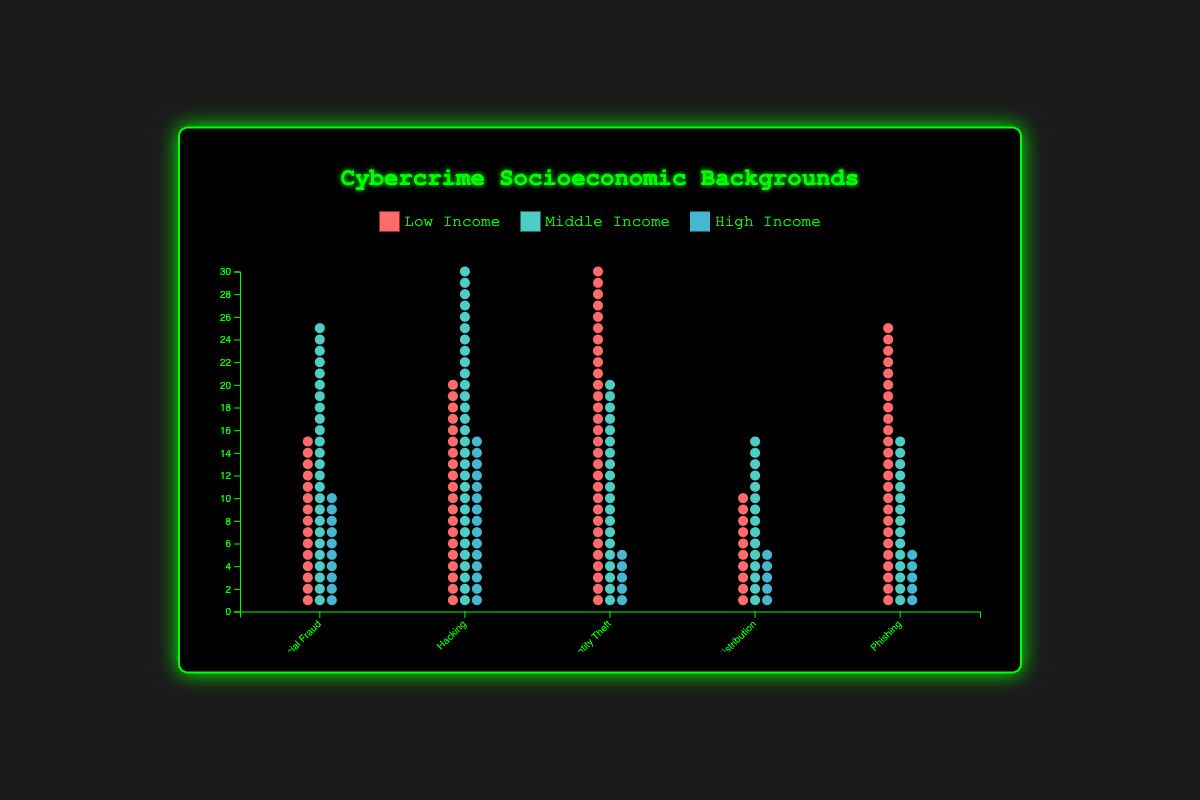What category has the highest representation of low-income cybercriminals? Look at the bars representing low-income backgrounds across all categories. The category with the tallest bar in the "low-income" color represents the highest count.
Answer: Identity Theft Which category has the least participation from high-income backgrounds? Observe the bars representing high-income backgrounds across all categories. The category with the shortest bar in the "high-income" color signifies the least count.
Answer: Identity Theft, Malware Distribution, Phishing What is the total number of middle-income individuals involved in cybercrimes? Sum up the values for middle-income individuals from all categories. 25 (Financial Fraud) + 30 (Hacking) + 20 (Identity Theft) + 15 (Malware Distribution) + 15 (Phishing) = 105
Answer: 105 How does financial fraud compare to hacking in terms of low-income background representation? Compare the two bars representing low-income backgrounds for Financial Fraud (15) and Hacking (20).
Answer: Hacking has more low-income representation What is the total number of cybercriminals involved in malware distribution? Sum the counts of low, middle, and high-income individuals in Malware Distribution. 10 (Low) + 15 (Middle) + 5 (High) = 30
Answer: 30 Which category has the most evenly distributed socioeconomic background representation? Analyze the height similarity of bars within each category. Identify the category where the bars are closest in height.
Answer: Financial Fraud What is the difference in low-income participation between identity theft and phishing? Subtract the number of low-income individuals in Phishing (25) from Identity Theft (30). 30 - 25 = 5
Answer: 5 What is the average number of high-income cybercriminals across all categories? Add the counts of high-income individuals in all categories and then divide by the number of categories. (10 + 15 + 5 + 5 + 5) / 5 = 8
Answer: 8 Which category has the highest overall participation across all income groups? Sum the counts of low, middle, and high-income individuals for each category, and identify the category with the highest total.
Answer: Hacking 